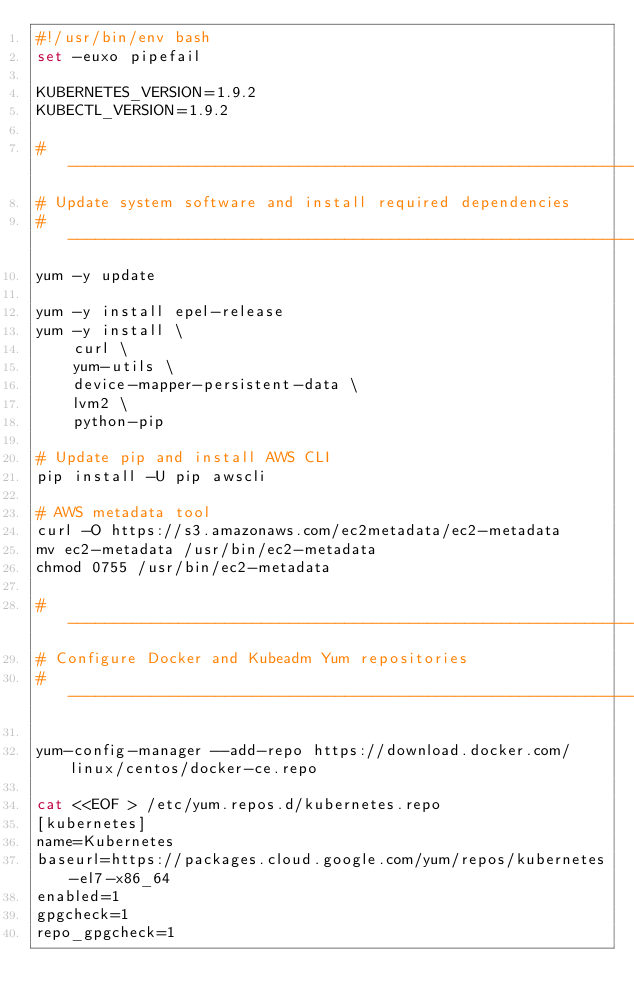<code> <loc_0><loc_0><loc_500><loc_500><_Bash_>#!/usr/bin/env bash
set -euxo pipefail

KUBERNETES_VERSION=1.9.2
KUBECTL_VERSION=1.9.2

# ----------------------------------------------------------------------------------------------------------------------
# Update system software and install required dependencies
# ----------------------------------------------------------------------------------------------------------------------
yum -y update

yum -y install epel-release
yum -y install \
    curl \
    yum-utils \
    device-mapper-persistent-data \
    lvm2 \
    python-pip

# Update pip and install AWS CLI
pip install -U pip awscli

# AWS metadata tool
curl -O https://s3.amazonaws.com/ec2metadata/ec2-metadata
mv ec2-metadata /usr/bin/ec2-metadata
chmod 0755 /usr/bin/ec2-metadata

# ----------------------------------------------------------------------------------------------------------------------
# Configure Docker and Kubeadm Yum repositories
# ----------------------------------------------------------------------------------------------------------------------

yum-config-manager --add-repo https://download.docker.com/linux/centos/docker-ce.repo

cat <<EOF > /etc/yum.repos.d/kubernetes.repo
[kubernetes]
name=Kubernetes
baseurl=https://packages.cloud.google.com/yum/repos/kubernetes-el7-x86_64
enabled=1
gpgcheck=1
repo_gpgcheck=1</code> 